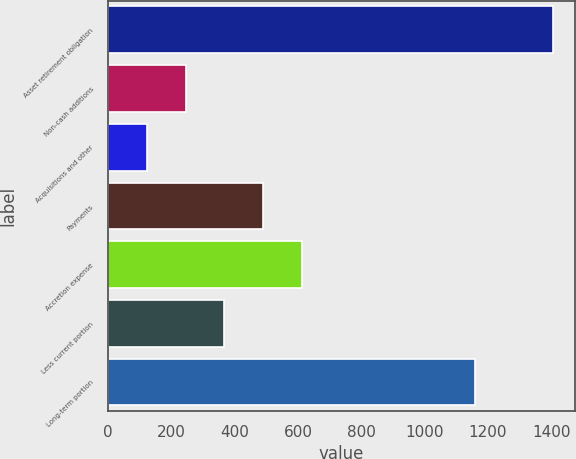Convert chart to OTSL. <chart><loc_0><loc_0><loc_500><loc_500><bar_chart><fcel>Asset retirement obligation<fcel>Non-cash additions<fcel>Acquisitions and other<fcel>Payments<fcel>Accretion expense<fcel>Less current portion<fcel>Long-term portion<nl><fcel>1404.62<fcel>245.32<fcel>122.91<fcel>490.14<fcel>612.55<fcel>367.73<fcel>1159.8<nl></chart> 